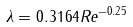<formula> <loc_0><loc_0><loc_500><loc_500>\lambda = 0 . 3 1 6 4 R e ^ { - 0 . 2 5 }</formula> 